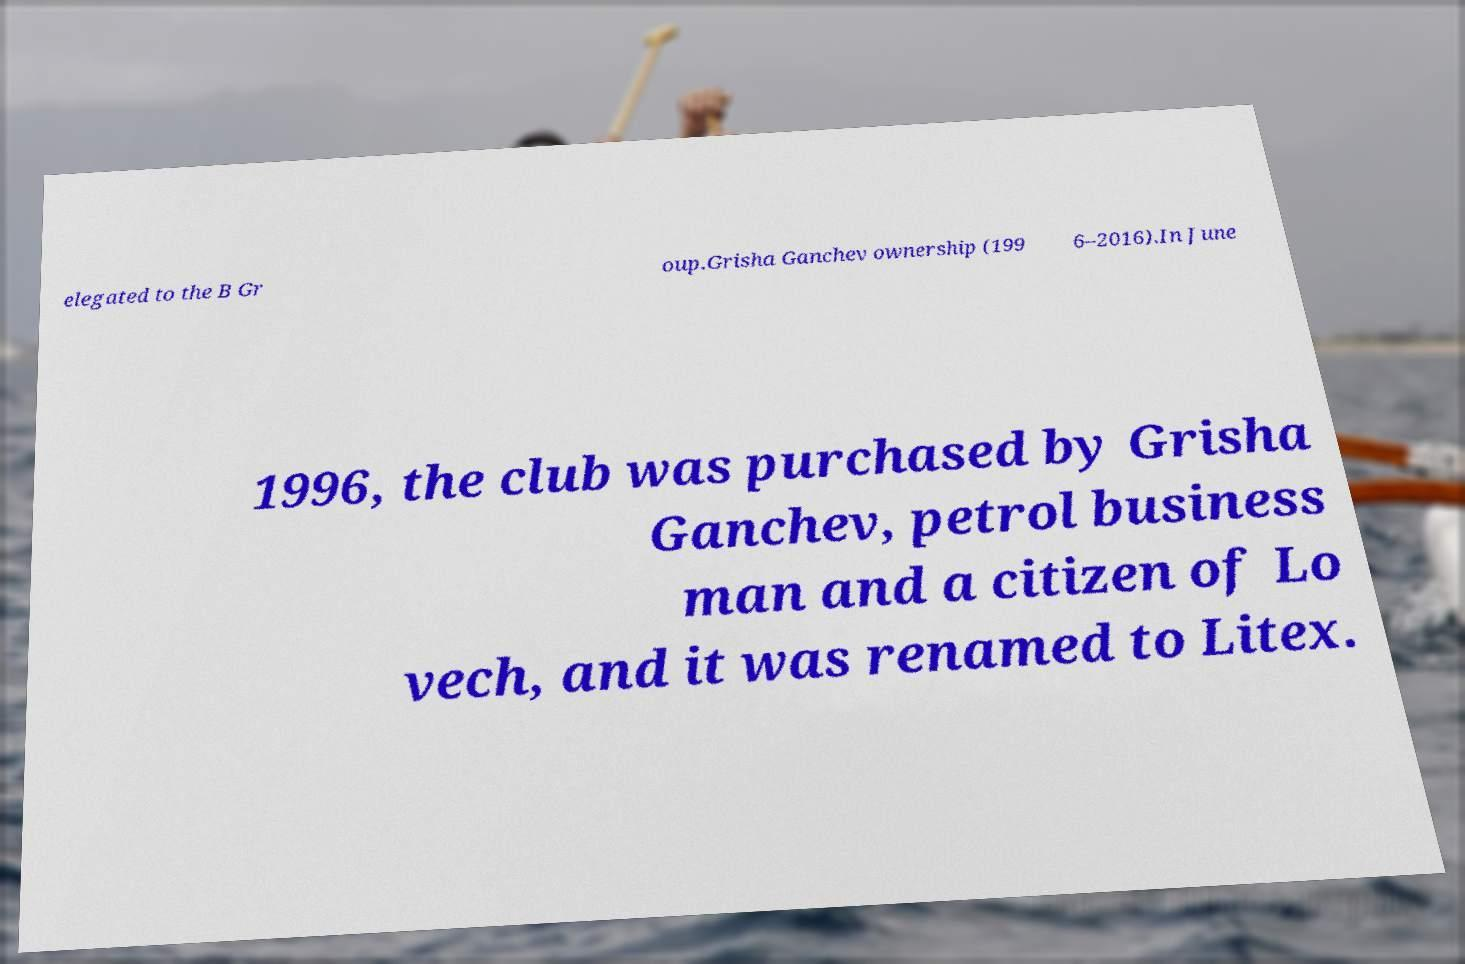Please identify and transcribe the text found in this image. elegated to the B Gr oup.Grisha Ganchev ownership (199 6–2016).In June 1996, the club was purchased by Grisha Ganchev, petrol business man and a citizen of Lo vech, and it was renamed to Litex. 